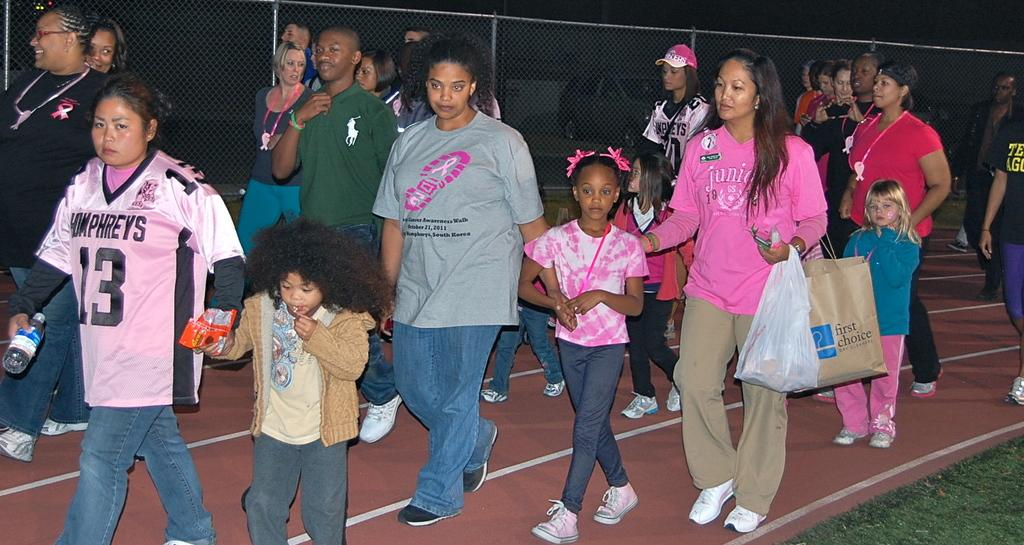<image>
Write a terse but informative summary of the picture. Group of people walking a on track for a charity event for breast cancer. 